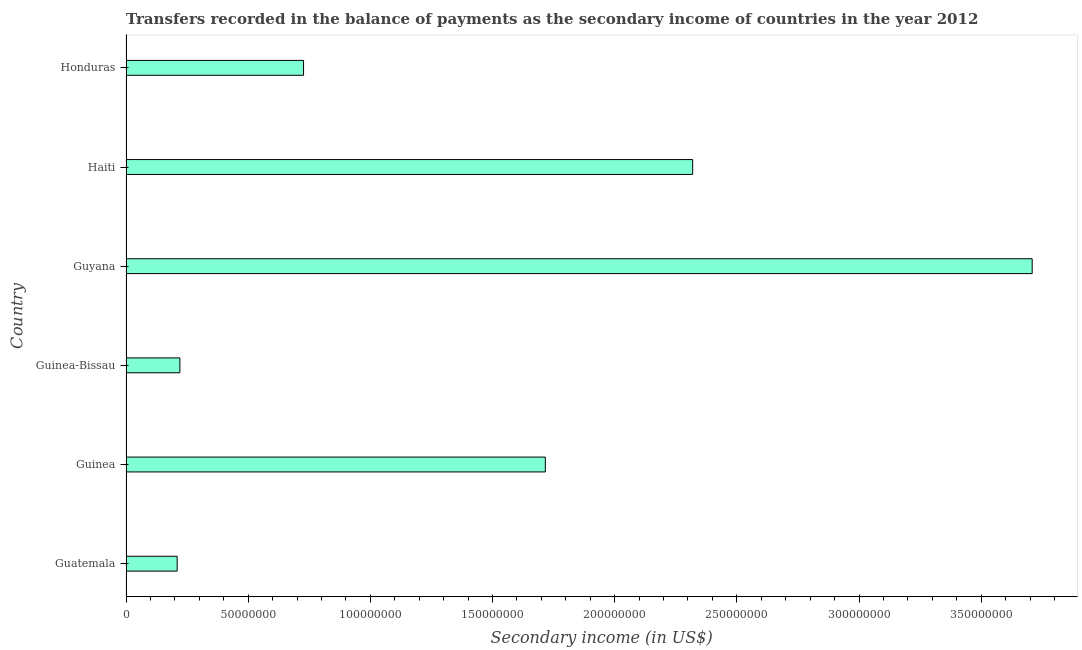Does the graph contain any zero values?
Offer a very short reply. No. What is the title of the graph?
Provide a short and direct response. Transfers recorded in the balance of payments as the secondary income of countries in the year 2012. What is the label or title of the X-axis?
Keep it short and to the point. Secondary income (in US$). What is the label or title of the Y-axis?
Your answer should be very brief. Country. What is the amount of secondary income in Guinea-Bissau?
Keep it short and to the point. 2.20e+07. Across all countries, what is the maximum amount of secondary income?
Keep it short and to the point. 3.71e+08. Across all countries, what is the minimum amount of secondary income?
Offer a very short reply. 2.09e+07. In which country was the amount of secondary income maximum?
Your answer should be very brief. Guyana. In which country was the amount of secondary income minimum?
Offer a terse response. Guatemala. What is the sum of the amount of secondary income?
Offer a very short reply. 8.90e+08. What is the difference between the amount of secondary income in Guyana and Haiti?
Offer a terse response. 1.39e+08. What is the average amount of secondary income per country?
Make the answer very short. 1.48e+08. What is the median amount of secondary income?
Provide a succinct answer. 1.22e+08. What is the ratio of the amount of secondary income in Guatemala to that in Guinea-Bissau?
Your answer should be very brief. 0.95. What is the difference between the highest and the second highest amount of secondary income?
Give a very brief answer. 1.39e+08. What is the difference between the highest and the lowest amount of secondary income?
Ensure brevity in your answer.  3.50e+08. How many bars are there?
Provide a short and direct response. 6. How many countries are there in the graph?
Your answer should be very brief. 6. What is the Secondary income (in US$) in Guatemala?
Provide a short and direct response. 2.09e+07. What is the Secondary income (in US$) in Guinea?
Your response must be concise. 1.72e+08. What is the Secondary income (in US$) in Guinea-Bissau?
Your answer should be compact. 2.20e+07. What is the Secondary income (in US$) in Guyana?
Ensure brevity in your answer.  3.71e+08. What is the Secondary income (in US$) in Haiti?
Provide a short and direct response. 2.32e+08. What is the Secondary income (in US$) in Honduras?
Your response must be concise. 7.27e+07. What is the difference between the Secondary income (in US$) in Guatemala and Guinea?
Offer a terse response. -1.51e+08. What is the difference between the Secondary income (in US$) in Guatemala and Guinea-Bissau?
Offer a terse response. -1.11e+06. What is the difference between the Secondary income (in US$) in Guatemala and Guyana?
Provide a short and direct response. -3.50e+08. What is the difference between the Secondary income (in US$) in Guatemala and Haiti?
Make the answer very short. -2.11e+08. What is the difference between the Secondary income (in US$) in Guatemala and Honduras?
Make the answer very short. -5.17e+07. What is the difference between the Secondary income (in US$) in Guinea and Guinea-Bissau?
Give a very brief answer. 1.50e+08. What is the difference between the Secondary income (in US$) in Guinea and Guyana?
Provide a succinct answer. -1.99e+08. What is the difference between the Secondary income (in US$) in Guinea and Haiti?
Your answer should be very brief. -6.03e+07. What is the difference between the Secondary income (in US$) in Guinea and Honduras?
Offer a very short reply. 9.90e+07. What is the difference between the Secondary income (in US$) in Guinea-Bissau and Guyana?
Give a very brief answer. -3.49e+08. What is the difference between the Secondary income (in US$) in Guinea-Bissau and Haiti?
Your answer should be very brief. -2.10e+08. What is the difference between the Secondary income (in US$) in Guinea-Bissau and Honduras?
Offer a very short reply. -5.06e+07. What is the difference between the Secondary income (in US$) in Guyana and Haiti?
Keep it short and to the point. 1.39e+08. What is the difference between the Secondary income (in US$) in Guyana and Honduras?
Your response must be concise. 2.98e+08. What is the difference between the Secondary income (in US$) in Haiti and Honduras?
Give a very brief answer. 1.59e+08. What is the ratio of the Secondary income (in US$) in Guatemala to that in Guinea?
Provide a short and direct response. 0.12. What is the ratio of the Secondary income (in US$) in Guatemala to that in Guinea-Bissau?
Give a very brief answer. 0.95. What is the ratio of the Secondary income (in US$) in Guatemala to that in Guyana?
Your response must be concise. 0.06. What is the ratio of the Secondary income (in US$) in Guatemala to that in Haiti?
Provide a succinct answer. 0.09. What is the ratio of the Secondary income (in US$) in Guatemala to that in Honduras?
Keep it short and to the point. 0.29. What is the ratio of the Secondary income (in US$) in Guinea to that in Guinea-Bissau?
Keep it short and to the point. 7.79. What is the ratio of the Secondary income (in US$) in Guinea to that in Guyana?
Provide a succinct answer. 0.46. What is the ratio of the Secondary income (in US$) in Guinea to that in Haiti?
Make the answer very short. 0.74. What is the ratio of the Secondary income (in US$) in Guinea to that in Honduras?
Your answer should be very brief. 2.36. What is the ratio of the Secondary income (in US$) in Guinea-Bissau to that in Guyana?
Your answer should be very brief. 0.06. What is the ratio of the Secondary income (in US$) in Guinea-Bissau to that in Haiti?
Offer a very short reply. 0.1. What is the ratio of the Secondary income (in US$) in Guinea-Bissau to that in Honduras?
Keep it short and to the point. 0.3. What is the ratio of the Secondary income (in US$) in Guyana to that in Haiti?
Make the answer very short. 1.6. What is the ratio of the Secondary income (in US$) in Guyana to that in Honduras?
Your response must be concise. 5.1. What is the ratio of the Secondary income (in US$) in Haiti to that in Honduras?
Your answer should be compact. 3.19. 